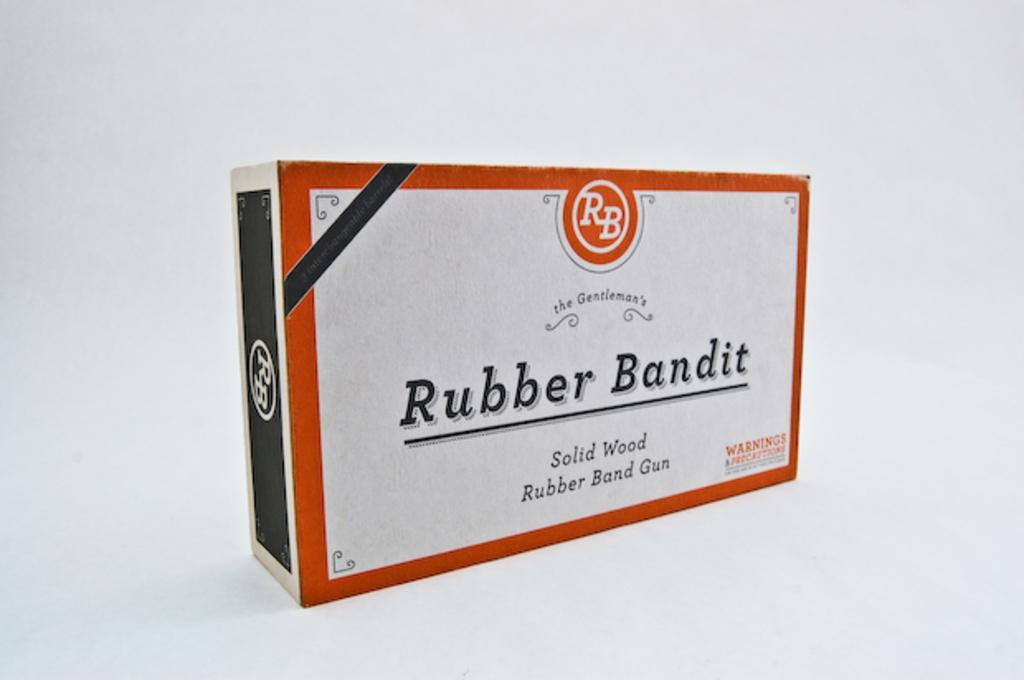<image>
Offer a succinct explanation of the picture presented. A Rubber Bandit box with solid wood rubber band gun 